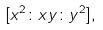Convert formula to latex. <formula><loc_0><loc_0><loc_500><loc_500>[ x ^ { 2 } \colon x y \colon y ^ { 2 } ] ,</formula> 